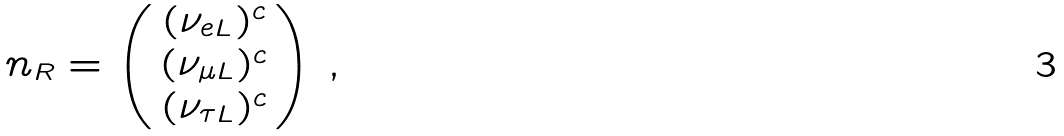<formula> <loc_0><loc_0><loc_500><loc_500>n _ { R } = \left ( \begin{array} { c } ( \nu _ { e L } ) ^ { c } \\ ( \nu _ { \mu L } ) ^ { c } \\ ( \nu _ { \tau L } ) ^ { c } \end{array} \right ) \, ,</formula> 